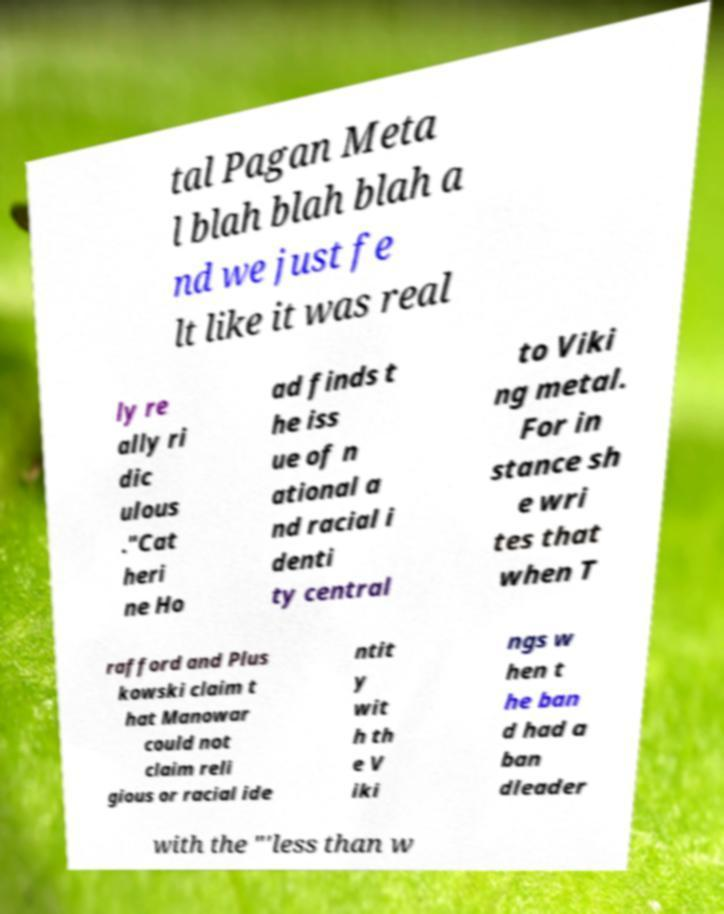There's text embedded in this image that I need extracted. Can you transcribe it verbatim? tal Pagan Meta l blah blah blah a nd we just fe lt like it was real ly re ally ri dic ulous ."Cat heri ne Ho ad finds t he iss ue of n ational a nd racial i denti ty central to Viki ng metal. For in stance sh e wri tes that when T rafford and Plus kowski claim t hat Manowar could not claim reli gious or racial ide ntit y wit h th e V iki ngs w hen t he ban d had a ban dleader with the "'less than w 